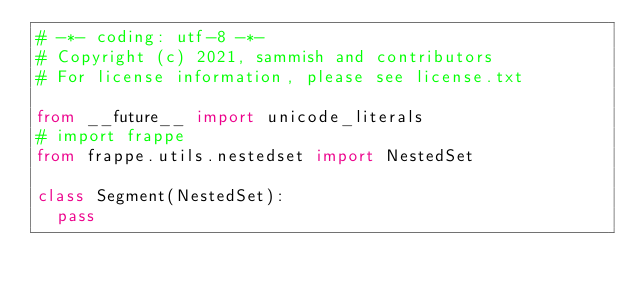Convert code to text. <code><loc_0><loc_0><loc_500><loc_500><_Python_># -*- coding: utf-8 -*-
# Copyright (c) 2021, sammish and contributors
# For license information, please see license.txt

from __future__ import unicode_literals
# import frappe
from frappe.utils.nestedset import NestedSet

class Segment(NestedSet):
	pass
</code> 